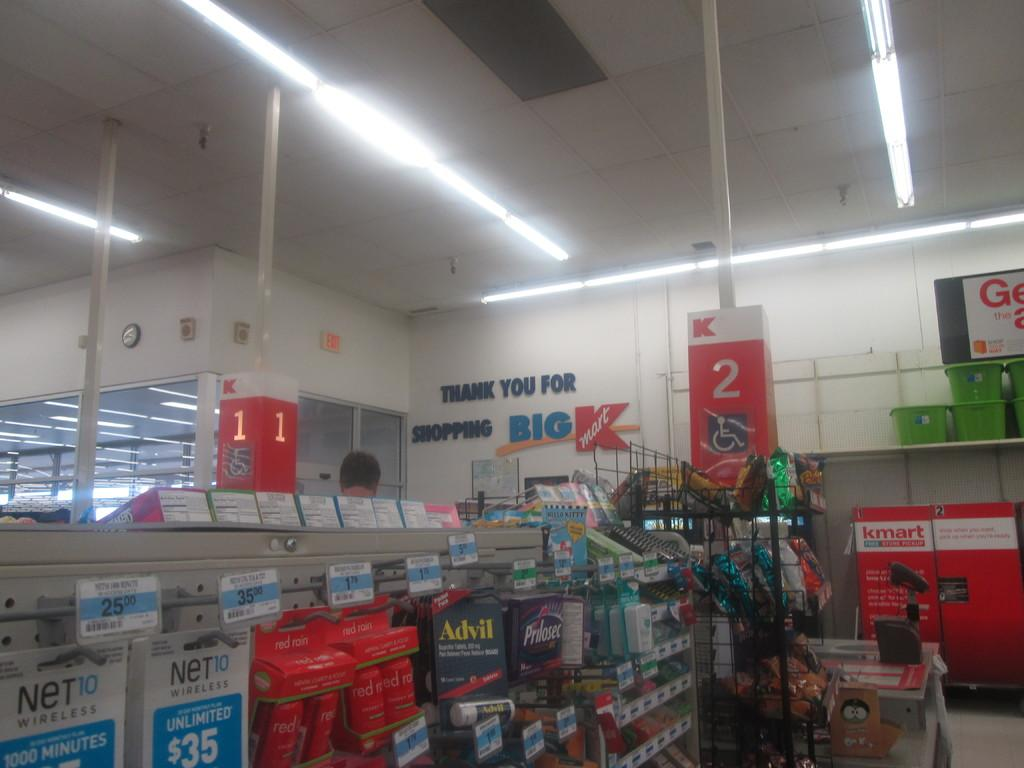<image>
Summarize the visual content of the image. Store that says "Thank you for Shopping" in the front. 